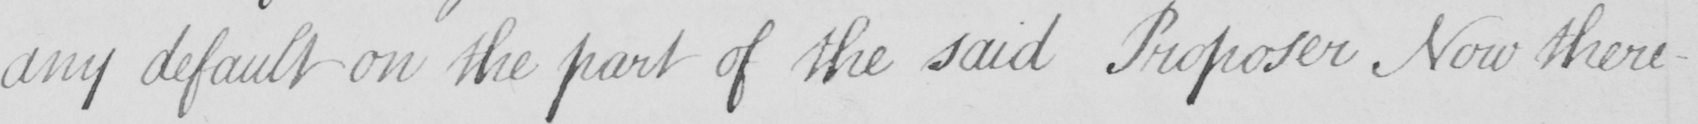Transcribe the text shown in this historical manuscript line. any default on the part of the said Proposer Now there- 